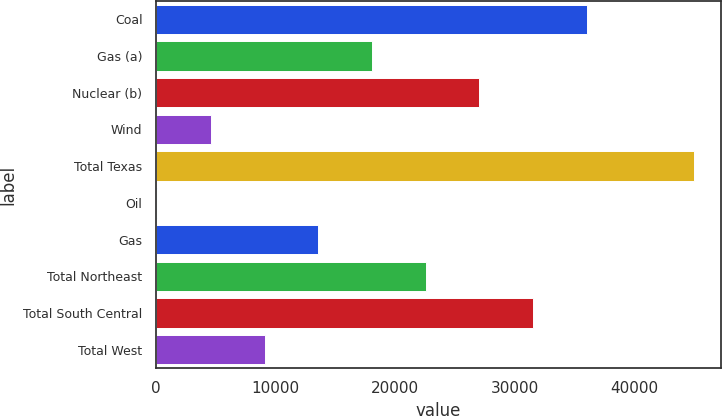Convert chart to OTSL. <chart><loc_0><loc_0><loc_500><loc_500><bar_chart><fcel>Coal<fcel>Gas (a)<fcel>Nuclear (b)<fcel>Wind<fcel>Total Texas<fcel>Oil<fcel>Gas<fcel>Total Northeast<fcel>Total South Central<fcel>Total West<nl><fcel>36021.2<fcel>18077.6<fcel>27049.4<fcel>4619.9<fcel>44993<fcel>134<fcel>13591.7<fcel>22563.5<fcel>31535.3<fcel>9105.8<nl></chart> 